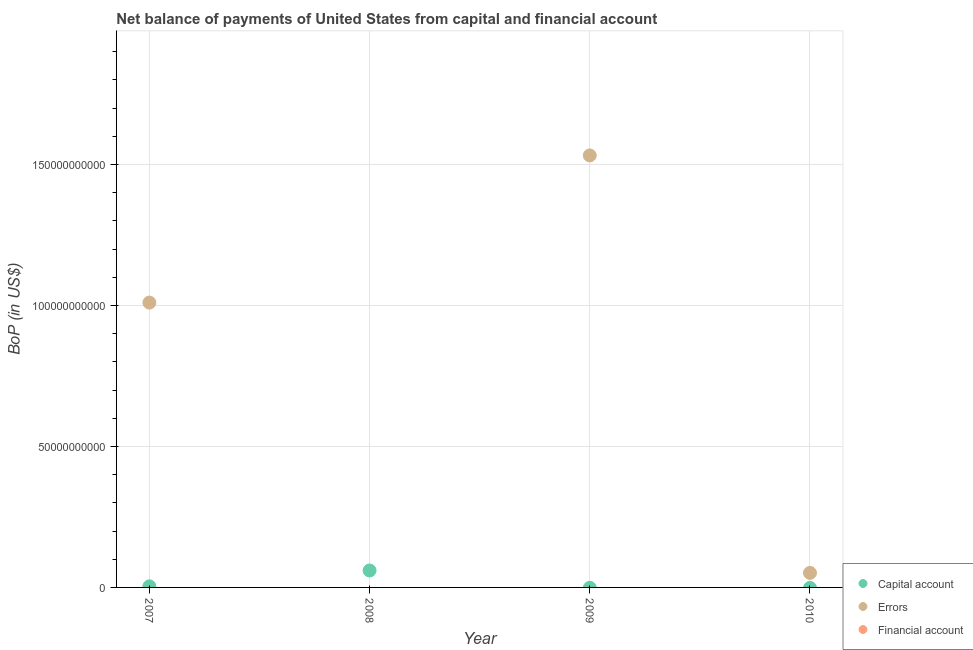Is the number of dotlines equal to the number of legend labels?
Provide a succinct answer. No. Across all years, what is the maximum amount of net capital account?
Your answer should be compact. 6.01e+09. In which year was the amount of net capital account maximum?
Your answer should be compact. 2008. What is the total amount of financial account in the graph?
Your answer should be compact. 0. What is the difference between the amount of errors in 2007 and that in 2009?
Provide a succinct answer. -5.22e+1. What is the average amount of errors per year?
Make the answer very short. 6.48e+1. Is the amount of errors in 2007 less than that in 2009?
Keep it short and to the point. Yes. What is the difference between the highest and the second highest amount of errors?
Your response must be concise. 5.22e+1. What is the difference between the highest and the lowest amount of net capital account?
Ensure brevity in your answer.  6.01e+09. Is the sum of the amount of errors in 2007 and 2009 greater than the maximum amount of net capital account across all years?
Offer a very short reply. Yes. How many dotlines are there?
Make the answer very short. 2. How many years are there in the graph?
Your response must be concise. 4. What is the difference between two consecutive major ticks on the Y-axis?
Keep it short and to the point. 5.00e+1. Does the graph contain any zero values?
Make the answer very short. Yes. Where does the legend appear in the graph?
Ensure brevity in your answer.  Bottom right. How many legend labels are there?
Make the answer very short. 3. What is the title of the graph?
Make the answer very short. Net balance of payments of United States from capital and financial account. Does "Female employers" appear as one of the legend labels in the graph?
Your answer should be compact. No. What is the label or title of the Y-axis?
Offer a terse response. BoP (in US$). What is the BoP (in US$) of Capital account in 2007?
Provide a short and direct response. 3.84e+08. What is the BoP (in US$) in Errors in 2007?
Give a very brief answer. 1.01e+11. What is the BoP (in US$) of Capital account in 2008?
Provide a short and direct response. 6.01e+09. What is the BoP (in US$) of Errors in 2009?
Your response must be concise. 1.53e+11. What is the BoP (in US$) in Financial account in 2009?
Ensure brevity in your answer.  0. What is the BoP (in US$) in Errors in 2010?
Your answer should be compact. 5.15e+09. Across all years, what is the maximum BoP (in US$) in Capital account?
Ensure brevity in your answer.  6.01e+09. Across all years, what is the maximum BoP (in US$) in Errors?
Your answer should be compact. 1.53e+11. Across all years, what is the minimum BoP (in US$) in Capital account?
Give a very brief answer. 0. Across all years, what is the minimum BoP (in US$) in Errors?
Your response must be concise. 0. What is the total BoP (in US$) in Capital account in the graph?
Provide a short and direct response. 6.40e+09. What is the total BoP (in US$) of Errors in the graph?
Offer a terse response. 2.59e+11. What is the difference between the BoP (in US$) in Capital account in 2007 and that in 2008?
Your answer should be compact. -5.63e+09. What is the difference between the BoP (in US$) in Errors in 2007 and that in 2009?
Make the answer very short. -5.22e+1. What is the difference between the BoP (in US$) of Errors in 2007 and that in 2010?
Provide a short and direct response. 9.59e+1. What is the difference between the BoP (in US$) of Errors in 2009 and that in 2010?
Your answer should be compact. 1.48e+11. What is the difference between the BoP (in US$) in Capital account in 2007 and the BoP (in US$) in Errors in 2009?
Offer a very short reply. -1.53e+11. What is the difference between the BoP (in US$) in Capital account in 2007 and the BoP (in US$) in Errors in 2010?
Ensure brevity in your answer.  -4.76e+09. What is the difference between the BoP (in US$) in Capital account in 2008 and the BoP (in US$) in Errors in 2009?
Your answer should be very brief. -1.47e+11. What is the difference between the BoP (in US$) in Capital account in 2008 and the BoP (in US$) in Errors in 2010?
Offer a very short reply. 8.63e+08. What is the average BoP (in US$) in Capital account per year?
Offer a very short reply. 1.60e+09. What is the average BoP (in US$) of Errors per year?
Offer a terse response. 6.48e+1. What is the average BoP (in US$) of Financial account per year?
Provide a succinct answer. 0. In the year 2007, what is the difference between the BoP (in US$) in Capital account and BoP (in US$) in Errors?
Provide a succinct answer. -1.01e+11. What is the ratio of the BoP (in US$) of Capital account in 2007 to that in 2008?
Provide a succinct answer. 0.06. What is the ratio of the BoP (in US$) in Errors in 2007 to that in 2009?
Ensure brevity in your answer.  0.66. What is the ratio of the BoP (in US$) of Errors in 2007 to that in 2010?
Your answer should be compact. 19.62. What is the ratio of the BoP (in US$) in Errors in 2009 to that in 2010?
Offer a very short reply. 29.76. What is the difference between the highest and the second highest BoP (in US$) of Errors?
Your answer should be very brief. 5.22e+1. What is the difference between the highest and the lowest BoP (in US$) of Capital account?
Provide a succinct answer. 6.01e+09. What is the difference between the highest and the lowest BoP (in US$) of Errors?
Provide a succinct answer. 1.53e+11. 